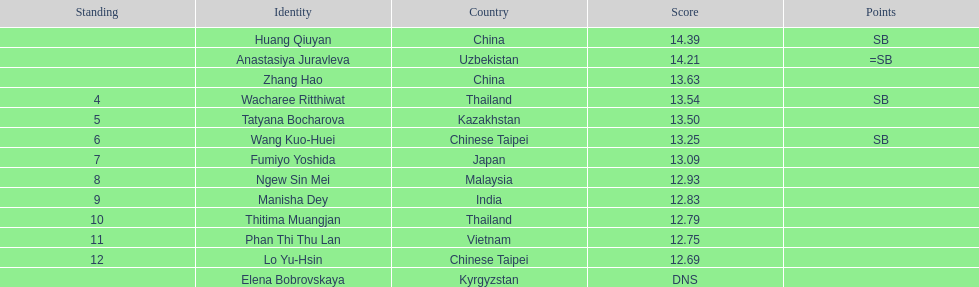Which country came in first? China. 